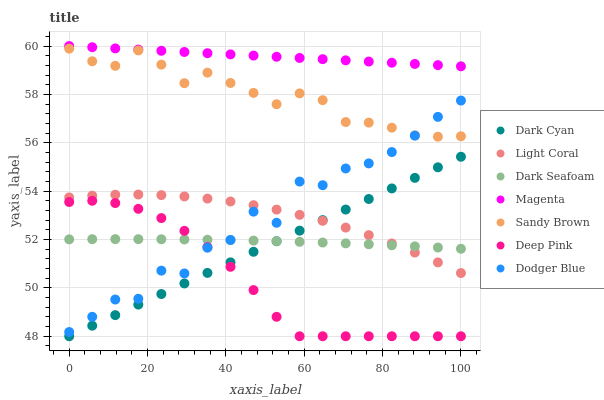Does Deep Pink have the minimum area under the curve?
Answer yes or no. Yes. Does Magenta have the maximum area under the curve?
Answer yes or no. Yes. Does Light Coral have the minimum area under the curve?
Answer yes or no. No. Does Light Coral have the maximum area under the curve?
Answer yes or no. No. Is Dark Cyan the smoothest?
Answer yes or no. Yes. Is Dodger Blue the roughest?
Answer yes or no. Yes. Is Light Coral the smoothest?
Answer yes or no. No. Is Light Coral the roughest?
Answer yes or no. No. Does Deep Pink have the lowest value?
Answer yes or no. Yes. Does Light Coral have the lowest value?
Answer yes or no. No. Does Magenta have the highest value?
Answer yes or no. Yes. Does Light Coral have the highest value?
Answer yes or no. No. Is Dark Cyan less than Sandy Brown?
Answer yes or no. Yes. Is Sandy Brown greater than Light Coral?
Answer yes or no. Yes. Does Dark Seafoam intersect Light Coral?
Answer yes or no. Yes. Is Dark Seafoam less than Light Coral?
Answer yes or no. No. Is Dark Seafoam greater than Light Coral?
Answer yes or no. No. Does Dark Cyan intersect Sandy Brown?
Answer yes or no. No. 